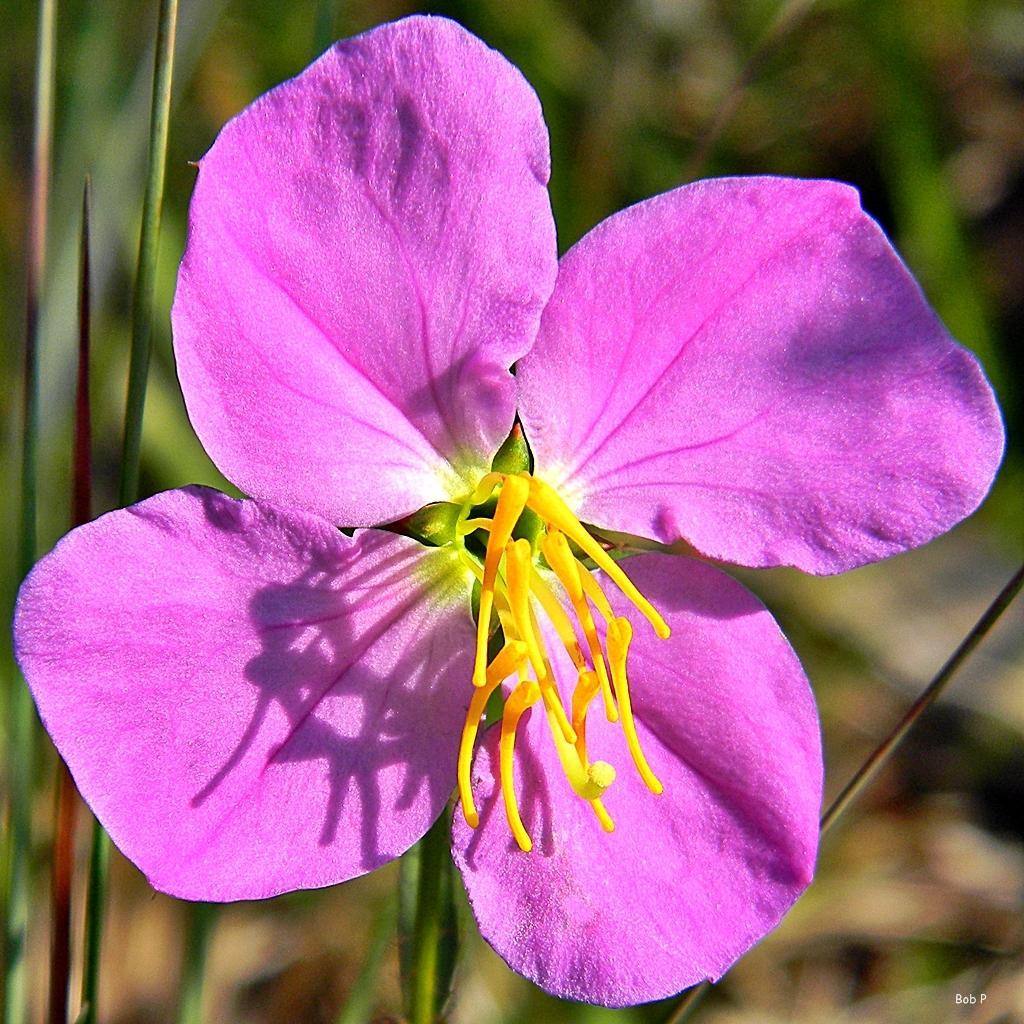How would you summarize this image in a sentence or two? In this image, I can see a flower, which is violet in color. The background looks blurry. At the bottom right corner of the image, I can see the watermark. 